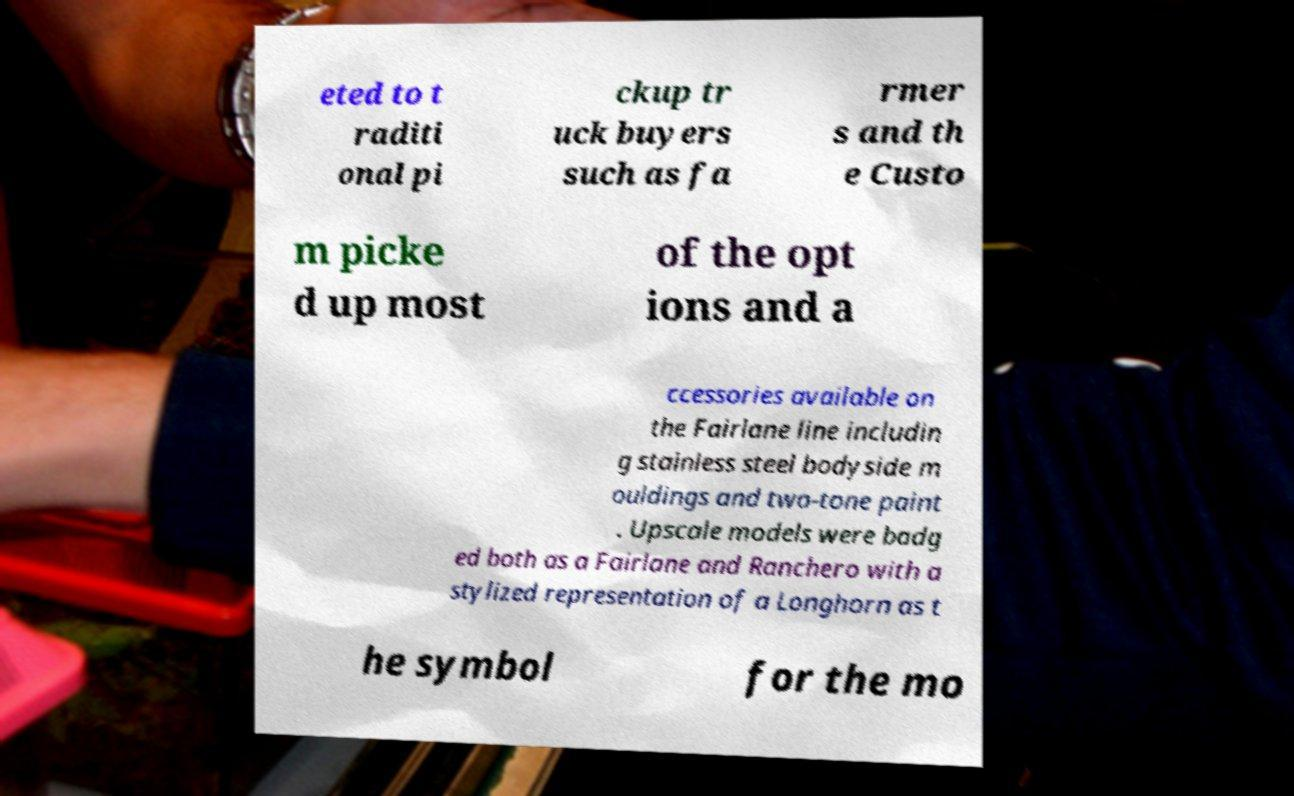I need the written content from this picture converted into text. Can you do that? eted to t raditi onal pi ckup tr uck buyers such as fa rmer s and th e Custo m picke d up most of the opt ions and a ccessories available on the Fairlane line includin g stainless steel bodyside m ouldings and two-tone paint . Upscale models were badg ed both as a Fairlane and Ranchero with a stylized representation of a Longhorn as t he symbol for the mo 